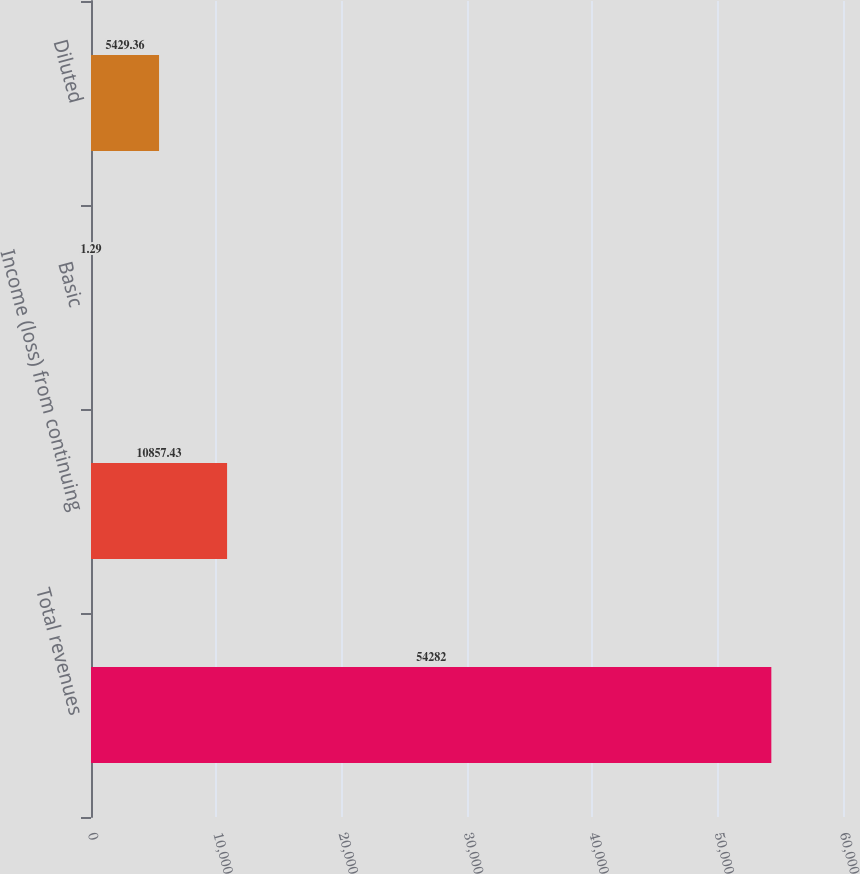Convert chart to OTSL. <chart><loc_0><loc_0><loc_500><loc_500><bar_chart><fcel>Total revenues<fcel>Income (loss) from continuing<fcel>Basic<fcel>Diluted<nl><fcel>54282<fcel>10857.4<fcel>1.29<fcel>5429.36<nl></chart> 